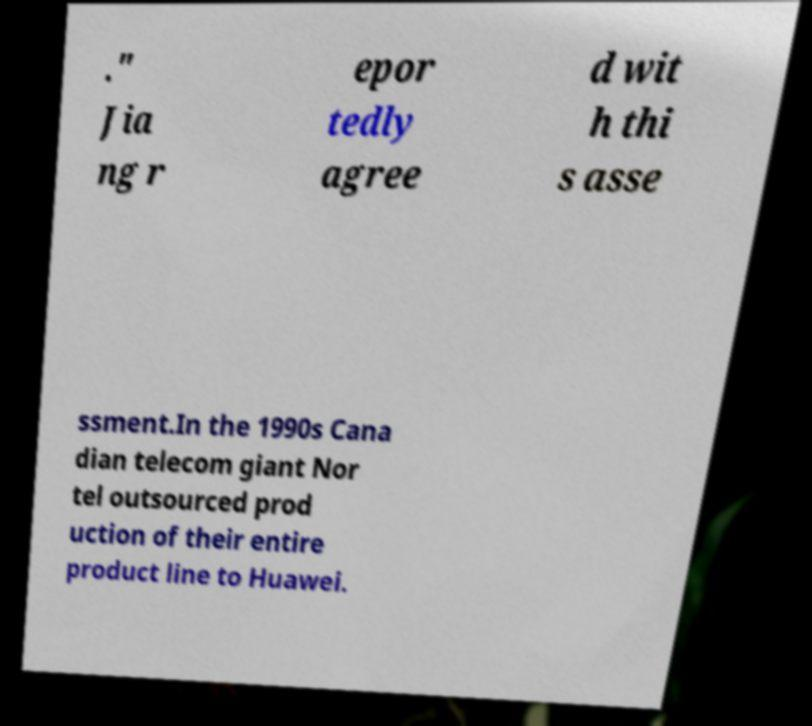Could you extract and type out the text from this image? ." Jia ng r epor tedly agree d wit h thi s asse ssment.In the 1990s Cana dian telecom giant Nor tel outsourced prod uction of their entire product line to Huawei. 